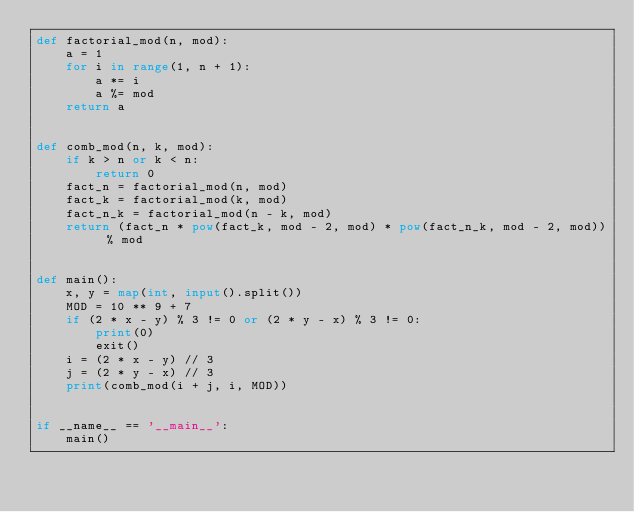<code> <loc_0><loc_0><loc_500><loc_500><_Python_>def factorial_mod(n, mod):
    a = 1
    for i in range(1, n + 1):
        a *= i
        a %= mod
    return a


def comb_mod(n, k, mod):
    if k > n or k < n:
        return 0
    fact_n = factorial_mod(n, mod)
    fact_k = factorial_mod(k, mod)
    fact_n_k = factorial_mod(n - k, mod)
    return (fact_n * pow(fact_k, mod - 2, mod) * pow(fact_n_k, mod - 2, mod)) % mod


def main():
    x, y = map(int, input().split())
    MOD = 10 ** 9 + 7
    if (2 * x - y) % 3 != 0 or (2 * y - x) % 3 != 0:
        print(0)
        exit()
    i = (2 * x - y) // 3
    j = (2 * y - x) // 3
    print(comb_mod(i + j, i, MOD))


if __name__ == '__main__':
    main()
</code> 